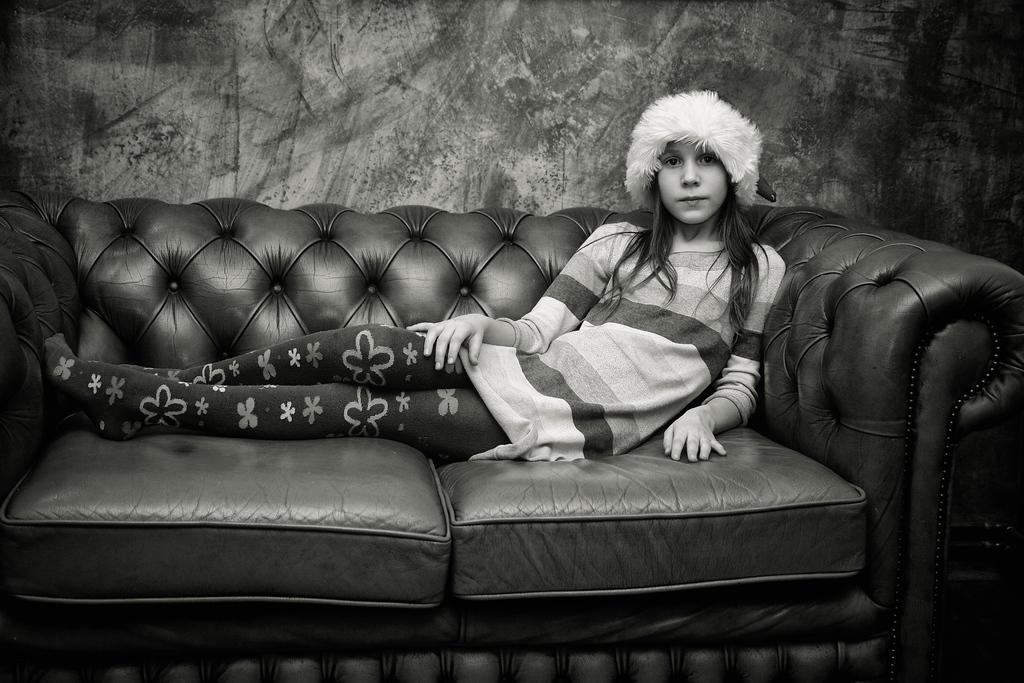Please provide a concise description of this image. In the image we can see there is a girl who is sitting on sofa and she is wearing a white hat and the image is in black and white colour. 